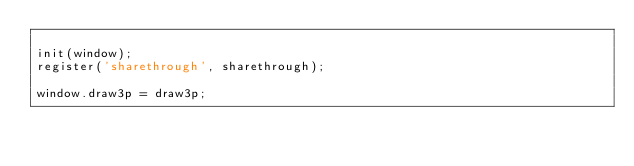Convert code to text. <code><loc_0><loc_0><loc_500><loc_500><_JavaScript_>
init(window);
register('sharethrough', sharethrough);

window.draw3p = draw3p;
</code> 